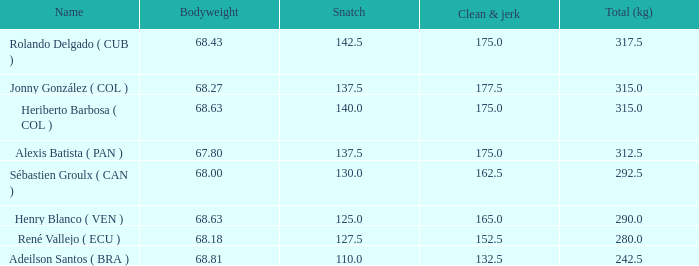Considering a total weight of 315 kg and a bodyweight of 68.63 kg, how many clean and jerk snatches surpassed 132.5? 1.0. 